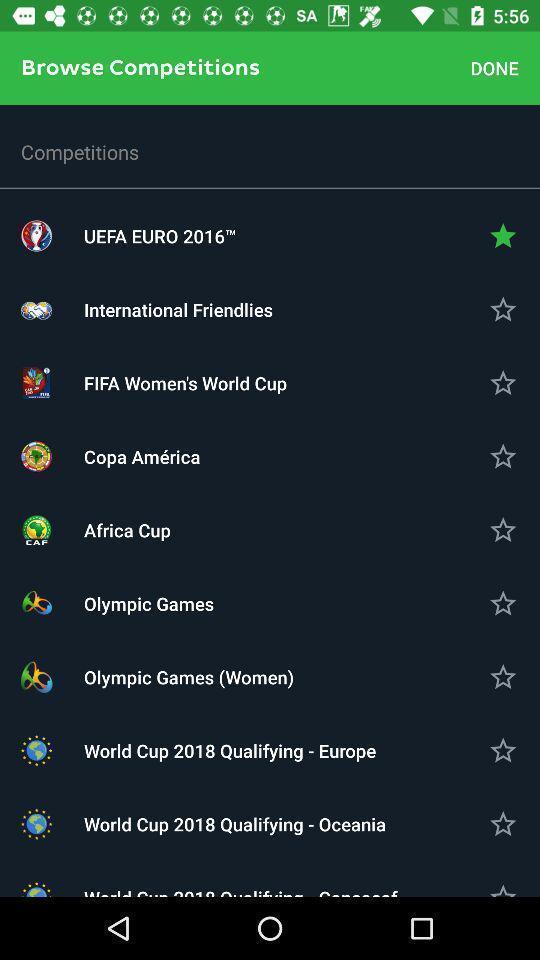Describe the key features of this screenshot. Window displaying about all sports competition. 